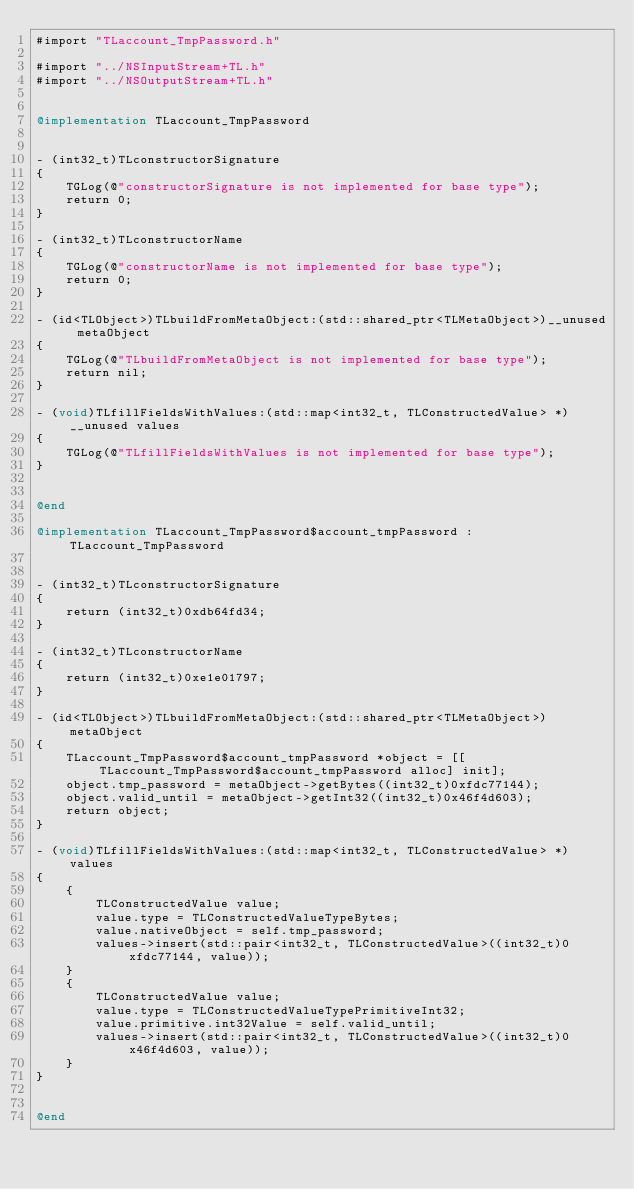Convert code to text. <code><loc_0><loc_0><loc_500><loc_500><_ObjectiveC_>#import "TLaccount_TmpPassword.h"

#import "../NSInputStream+TL.h"
#import "../NSOutputStream+TL.h"


@implementation TLaccount_TmpPassword


- (int32_t)TLconstructorSignature
{
    TGLog(@"constructorSignature is not implemented for base type");
    return 0;
}

- (int32_t)TLconstructorName
{
    TGLog(@"constructorName is not implemented for base type");
    return 0;
}

- (id<TLObject>)TLbuildFromMetaObject:(std::shared_ptr<TLMetaObject>)__unused metaObject
{
    TGLog(@"TLbuildFromMetaObject is not implemented for base type");
    return nil;
}

- (void)TLfillFieldsWithValues:(std::map<int32_t, TLConstructedValue> *)__unused values
{
    TGLog(@"TLfillFieldsWithValues is not implemented for base type");
}


@end

@implementation TLaccount_TmpPassword$account_tmpPassword : TLaccount_TmpPassword


- (int32_t)TLconstructorSignature
{
    return (int32_t)0xdb64fd34;
}

- (int32_t)TLconstructorName
{
    return (int32_t)0xe1e01797;
}

- (id<TLObject>)TLbuildFromMetaObject:(std::shared_ptr<TLMetaObject>)metaObject
{
    TLaccount_TmpPassword$account_tmpPassword *object = [[TLaccount_TmpPassword$account_tmpPassword alloc] init];
    object.tmp_password = metaObject->getBytes((int32_t)0xfdc77144);
    object.valid_until = metaObject->getInt32((int32_t)0x46f4d603);
    return object;
}

- (void)TLfillFieldsWithValues:(std::map<int32_t, TLConstructedValue> *)values
{
    {
        TLConstructedValue value;
        value.type = TLConstructedValueTypeBytes;
        value.nativeObject = self.tmp_password;
        values->insert(std::pair<int32_t, TLConstructedValue>((int32_t)0xfdc77144, value));
    }
    {
        TLConstructedValue value;
        value.type = TLConstructedValueTypePrimitiveInt32;
        value.primitive.int32Value = self.valid_until;
        values->insert(std::pair<int32_t, TLConstructedValue>((int32_t)0x46f4d603, value));
    }
}


@end

</code> 